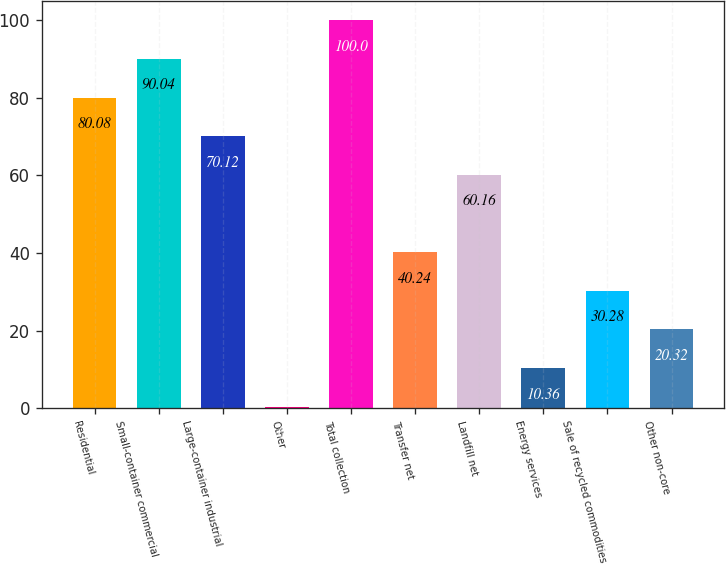Convert chart. <chart><loc_0><loc_0><loc_500><loc_500><bar_chart><fcel>Residential<fcel>Small-container commercial<fcel>Large-container industrial<fcel>Other<fcel>Total collection<fcel>Transfer net<fcel>Landfill net<fcel>Energy services<fcel>Sale of recycled commodities<fcel>Other non-core<nl><fcel>80.08<fcel>90.04<fcel>70.12<fcel>0.4<fcel>100<fcel>40.24<fcel>60.16<fcel>10.36<fcel>30.28<fcel>20.32<nl></chart> 